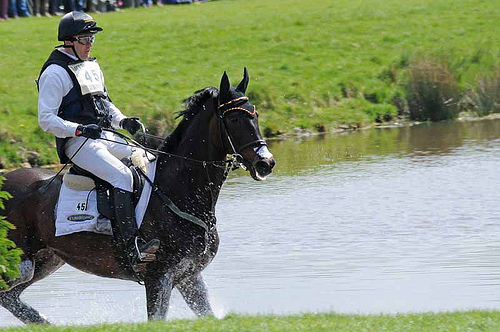Can you describe the man's attire in detail? The man is dressed in a white long-sleeved shirt and white trousers, which are likely part of his competitive equestrian attire. He is also wearing a black protective vest and a helmet for safety. The number 45 is visible on the bib he's wearing, indicating his participant number in the event. What could be the possible reasons for the horse's athletic appearance? The horse's athletic appearance can be attributed to rigorous training and a proper diet. It likely undergoes regular exercise routines and conditioning to build strength, stamina, and agility required for equestrian sports. Additionally, the horse might be bred from a lineage known for competitive success. Imagine the man and the horse are part of a historical event. Narrate the scene in detail. In the summer of 1495, amidst the verdant fields and sparkling brooks of the English countryside, a scene unfolded that would be remembered for generations. Sir Harold, a knight revered for his prowess and valor, guided his majestic steed, Thunder, through an impromptu tournament held in honor of the visiting monarch. The horse, its muscles rippling with each stride, glided effortlessly through the water course, evoking gasps of admiration from the assembled nobles. Dressed in shining armor, Sir Harold's white tabard, bearing his family crest, stood out prominently, a symbol of his undying loyalty to the crown. The gleam of the sun on his helmet and the clatter of hooves echoed through the vale, intertwining with the cheers of the crowd. This was not just a display of skill and dexterity but a testament to the ancient bond between a knight and his trusted steed, both symbols of honor, tradition, and the indomitable spirit of medieval chivalry. What are the practical purposes of the different gear worn by the rider and the horse? The rider's helmet and protective vest are practical safety measures to prevent injury during falls or collisions. The white clothing, while traditional, also helps keep the rider cool and reflects the sunlight. The horse's equipment, like the bridle and reins, helps the rider control and guide the horse. The saddle provides a secure and comfortable seat for the rider, while the protective leg gear shields the horse's legs from potential injuries during jumps or uneven terrains. 